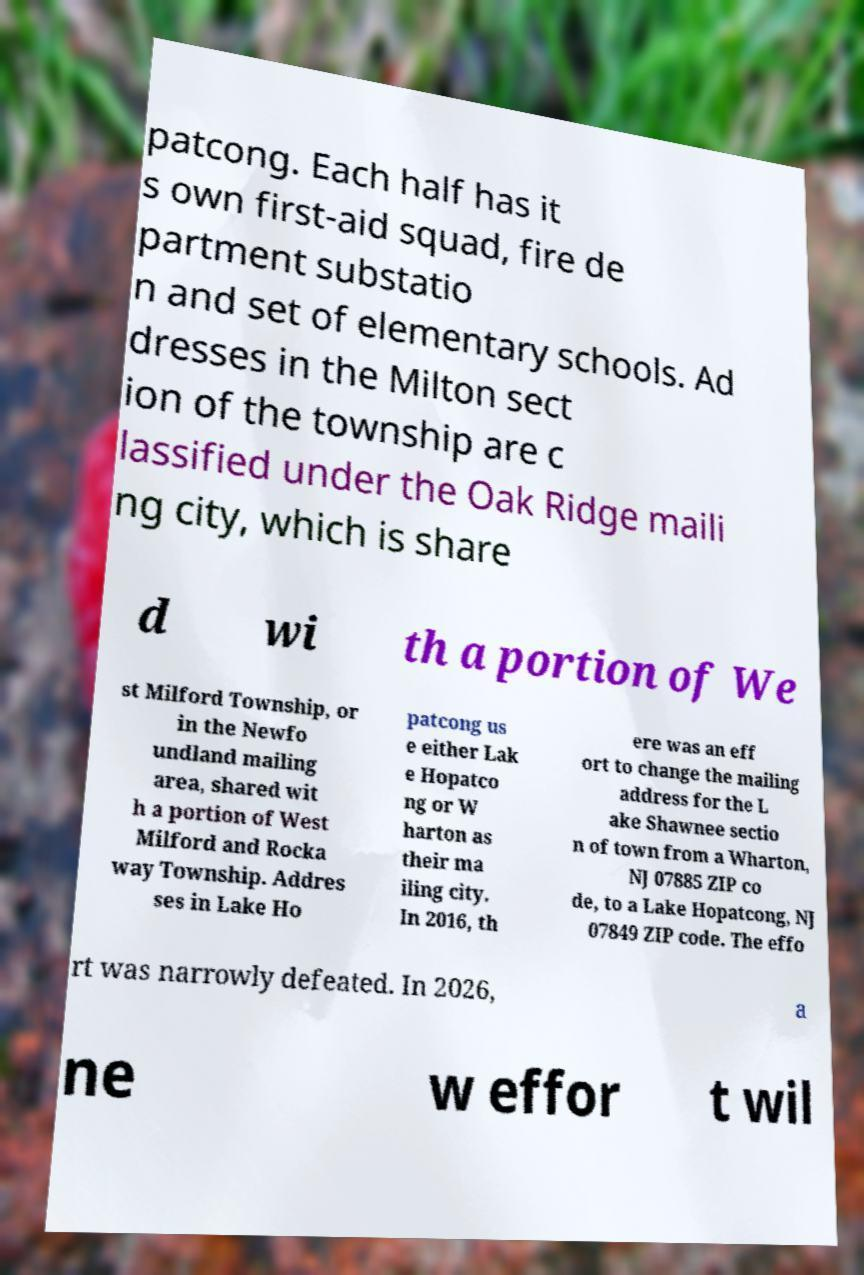For documentation purposes, I need the text within this image transcribed. Could you provide that? patcong. Each half has it s own first-aid squad, fire de partment substatio n and set of elementary schools. Ad dresses in the Milton sect ion of the township are c lassified under the Oak Ridge maili ng city, which is share d wi th a portion of We st Milford Township, or in the Newfo undland mailing area, shared wit h a portion of West Milford and Rocka way Township. Addres ses in Lake Ho patcong us e either Lak e Hopatco ng or W harton as their ma iling city. In 2016, th ere was an eff ort to change the mailing address for the L ake Shawnee sectio n of town from a Wharton, NJ 07885 ZIP co de, to a Lake Hopatcong, NJ 07849 ZIP code. The effo rt was narrowly defeated. In 2026, a ne w effor t wil 